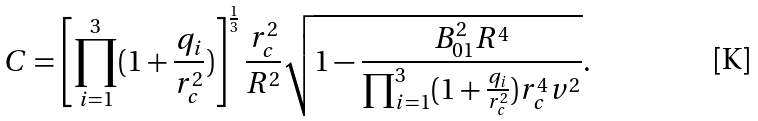<formula> <loc_0><loc_0><loc_500><loc_500>C = \left [ \prod _ { i = 1 } ^ { 3 } ( 1 + \frac { q _ { i } } { r _ { c } ^ { 2 } } ) \right ] ^ { \frac { 1 } { 3 } } \frac { r _ { c } ^ { 2 } } { R ^ { 2 } } \sqrt { 1 - \frac { B _ { 0 1 } ^ { 2 } R ^ { 4 } } { \prod _ { i = 1 } ^ { 3 } ( 1 + \frac { q _ { i } } { r _ { c } ^ { 2 } } ) r _ { c } ^ { 4 } v ^ { 2 } } } .</formula> 